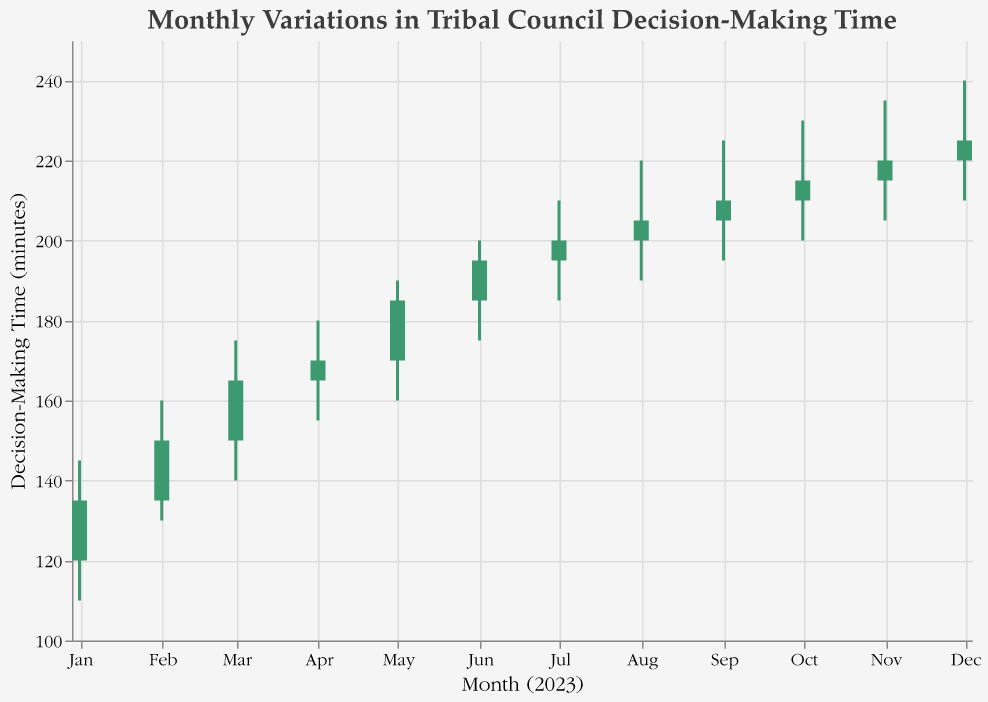What is the title of the chart? The title is at the top of the chart, in a large font. It reads "Monthly Variations in Tribal Council Decision-Making Time".
Answer: Monthly Variations in Tribal Council Decision-Making Time What time period does the chart cover? The x-axis shows months from January to December 2023. Each tick mark represents a month starting from January 2023 to December 2023.
Answer: January to December 2023 Which months had decision-making times closing significantly higher than they opened? The green bars indicate months where the closing value is higher than the opening value. From the chart, these months are January to September.
Answer: January to September How does the decision-making time in January compare to that in June? January shows an opening time of 120 minutes and a closing time of 135 minutes. June shows an opening time of 185 minutes and a closing time of 195 minutes. So, both the opening and closing times are higher in June compared to January.
Answer: Higher in June What is the range of the decision-making time in August? The range is the difference between the high and low values for the month. For August, the high is 220 minutes and the low is 190 minutes. So, the range is 220 - 190 = 30 minutes.
Answer: 30 minutes Which month had the highest decision-making time? By looking at the high values, December has the highest decision-making time with a high of 240 minutes.
Answer: December How does kinship representation correlate with decision-making times over the months? As kinship representation increases from January 0.65 to September 1.00, decision-making times also generally increase. However, after September, as kinship representation decreases, decision-making times don’t drop significantly.
Answer: Generally positive correlation up to September What is the median of the closing decision-making time across all months? To find the median, list the closing decision-making times: 135, 150, 165, 170, 185, 195, 200, 205, 210, 215, 220, 225. The middle values are 195 and 200. The median is (195+200)/2 = 197.5.
Answer: 197.5 minutes What trend can be observed about kinship representation and decision-making times from July to October? Kinship representation peaks in September at 1.00 and then declines. Decision-making times continue to rise until October before stabilizing.
Answer: Kinship representation declines, decision times rise then stabilize 